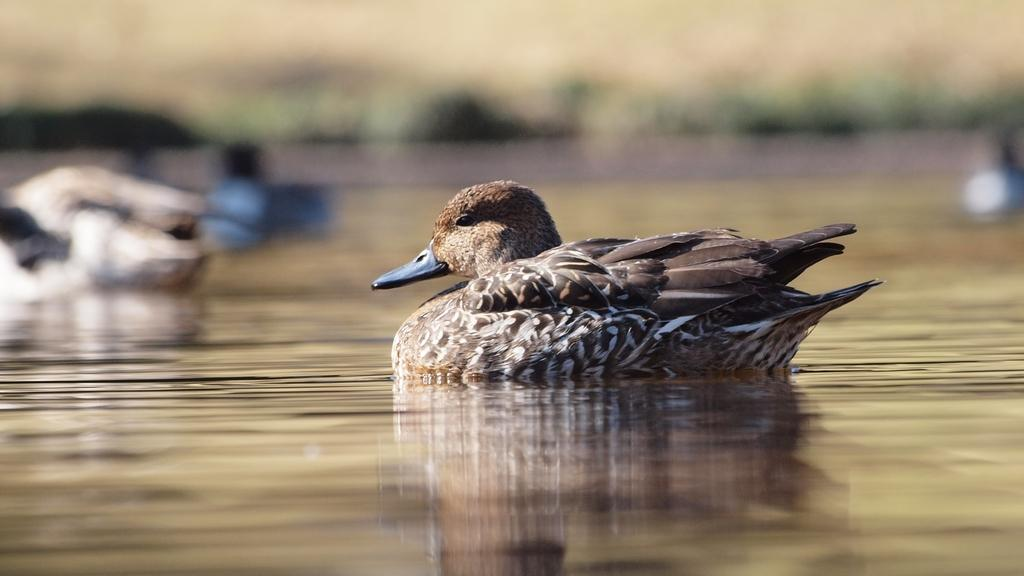What animal is present in the image? There is a duck in the image. Where is the duck located? The duck is on the water. What grade is the duck in the image? The image does not depict a grade or educational context, so it is not possible to determine the grade of the duck. 